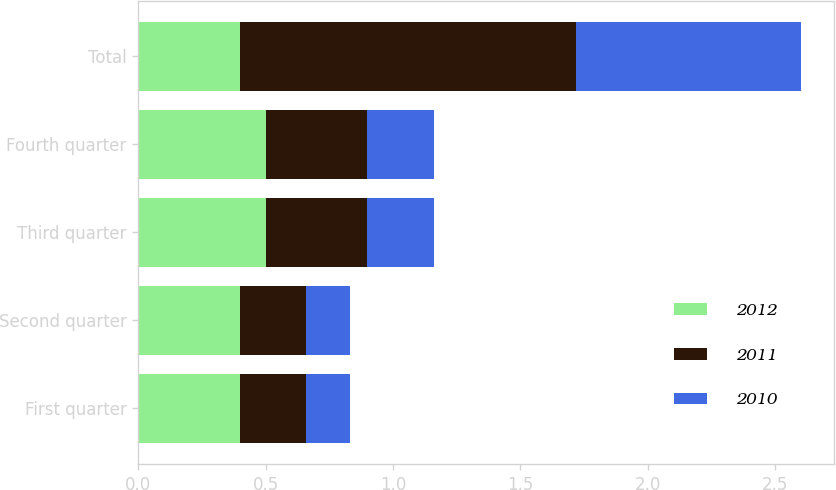Convert chart. <chart><loc_0><loc_0><loc_500><loc_500><stacked_bar_chart><ecel><fcel>First quarter<fcel>Second quarter<fcel>Third quarter<fcel>Fourth quarter<fcel>Total<nl><fcel>2012<fcel>0.4<fcel>0.4<fcel>0.5<fcel>0.5<fcel>0.4<nl><fcel>2011<fcel>0.26<fcel>0.26<fcel>0.4<fcel>0.4<fcel>1.32<nl><fcel>2010<fcel>0.17<fcel>0.17<fcel>0.26<fcel>0.26<fcel>0.88<nl></chart> 